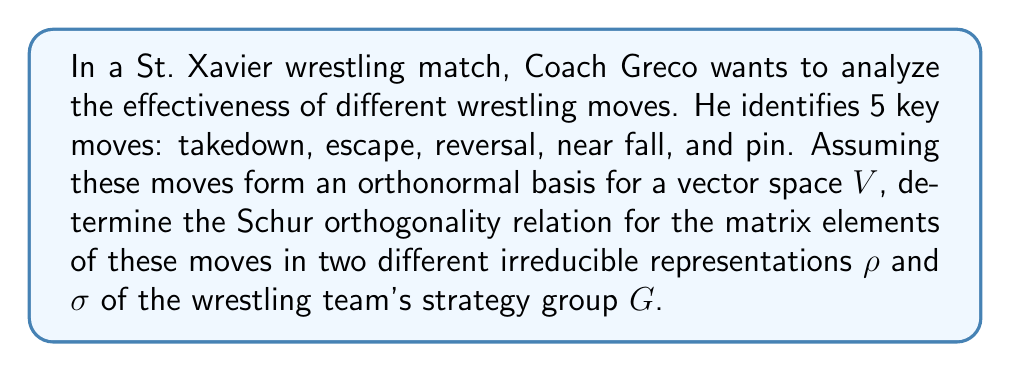Help me with this question. Let's approach this step-by-step:

1) First, recall the general form of the Schur orthogonality relations:

   $$\frac{1}{|G|} \sum_{g \in G} \rho_{ij}(g) \overline{\sigma_{kl}(g)} = \frac{\delta_{\rho\sigma}\delta_{ik}\delta_{jl}}{\dim \rho}$$

   Where $|G|$ is the order of the group, $\rho_{ij}$ and $\sigma_{kl}$ are matrix elements of the representations, and $\dim \rho$ is the dimension of the representation ρ.

2) In our wrestling context, G represents the strategy group of the wrestling team. Each element g ∈ G corresponds to a specific strategy or sequence of moves.

3) The 5 key moves (takedown, escape, reversal, near fall, and pin) form an orthonormal basis for the vector space V. This means that each representation ρ and σ will be 5-dimensional.

4) The matrix elements $\rho_{ij}(g)$ represent how the i-th move transforms into the j-th move under the strategy g in representation ρ. Similarly for $\sigma_{kl}(g)$.

5) The Kronecker delta $\delta_{\rho\sigma}$ ensures that the relation is non-zero only when ρ and σ are the same representation. $\delta_{ik}$ and $\delta_{jl}$ ensure that the relation is non-zero only when i=k and j=l.

6) Substituting these into the general formula, we get:

   $$\frac{1}{|G|} \sum_{g \in G} \rho_{ij}(g) \overline{\sigma_{kl}(g)} = \frac{\delta_{\rho\sigma}\delta_{ik}\delta_{jl}}{5}$$

   This is because $\dim \rho = 5$ for our 5-dimensional representations.

7) This relation holds for all i, j, k, l ∈ {1, 2, 3, 4, 5}, corresponding to our 5 wrestling moves.
Answer: $$\frac{1}{|G|} \sum_{g \in G} \rho_{ij}(g) \overline{\sigma_{kl}(g)} = \frac{\delta_{\rho\sigma}\delta_{ik}\delta_{jl}}{5}$$ 